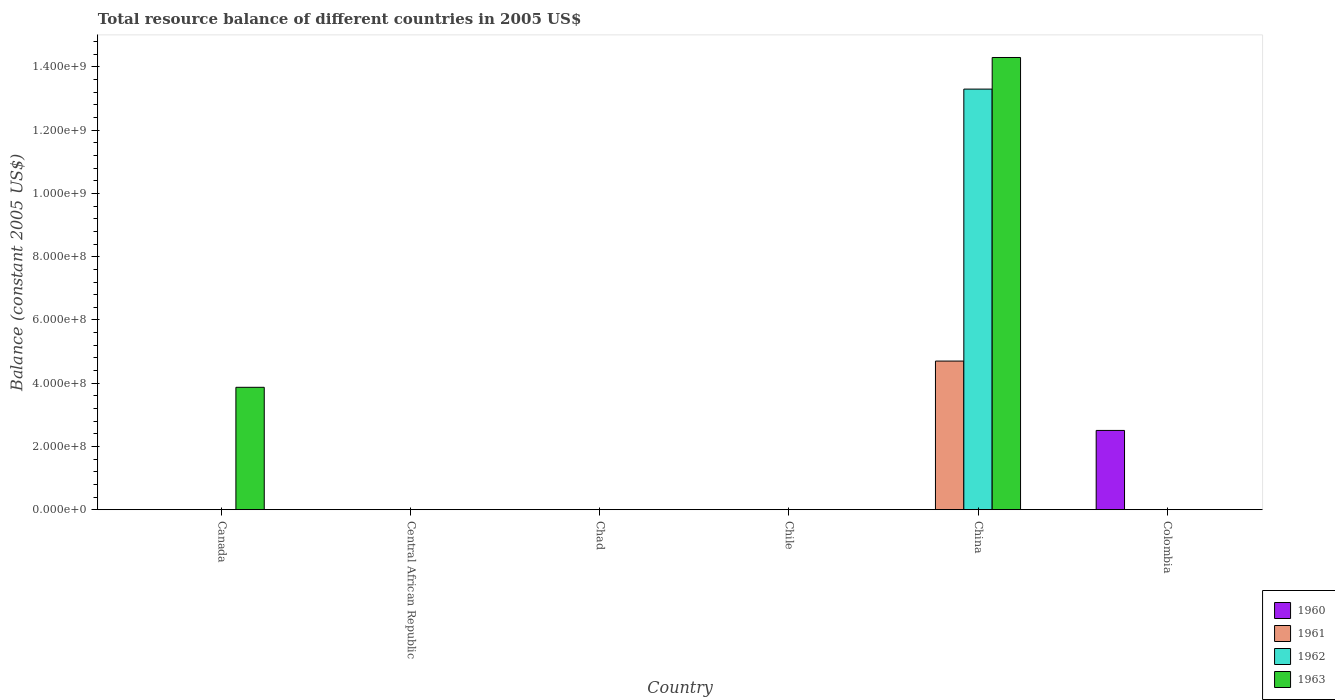How many different coloured bars are there?
Your answer should be very brief. 4. Are the number of bars per tick equal to the number of legend labels?
Provide a succinct answer. No. Are the number of bars on each tick of the X-axis equal?
Your answer should be compact. No. What is the label of the 1st group of bars from the left?
Keep it short and to the point. Canada. What is the total resource balance in 1961 in Chile?
Your answer should be very brief. 0. Across all countries, what is the maximum total resource balance in 1962?
Your response must be concise. 1.33e+09. What is the total total resource balance in 1960 in the graph?
Your answer should be compact. 2.51e+08. What is the difference between the total resource balance in 1961 in Colombia and the total resource balance in 1963 in China?
Offer a very short reply. -1.43e+09. What is the average total resource balance in 1962 per country?
Your answer should be very brief. 2.22e+08. What is the difference between the highest and the lowest total resource balance in 1962?
Provide a short and direct response. 1.33e+09. In how many countries, is the total resource balance in 1961 greater than the average total resource balance in 1961 taken over all countries?
Offer a very short reply. 1. Is it the case that in every country, the sum of the total resource balance in 1961 and total resource balance in 1960 is greater than the sum of total resource balance in 1962 and total resource balance in 1963?
Your answer should be very brief. No. Are all the bars in the graph horizontal?
Keep it short and to the point. No. Are the values on the major ticks of Y-axis written in scientific E-notation?
Your answer should be compact. Yes. Does the graph contain grids?
Keep it short and to the point. No. Where does the legend appear in the graph?
Provide a succinct answer. Bottom right. How many legend labels are there?
Make the answer very short. 4. How are the legend labels stacked?
Your answer should be very brief. Vertical. What is the title of the graph?
Keep it short and to the point. Total resource balance of different countries in 2005 US$. What is the label or title of the Y-axis?
Offer a very short reply. Balance (constant 2005 US$). What is the Balance (constant 2005 US$) in 1960 in Canada?
Ensure brevity in your answer.  0. What is the Balance (constant 2005 US$) in 1963 in Canada?
Offer a very short reply. 3.87e+08. What is the Balance (constant 2005 US$) of 1960 in Central African Republic?
Keep it short and to the point. 0. What is the Balance (constant 2005 US$) in 1961 in Central African Republic?
Provide a short and direct response. 0. What is the Balance (constant 2005 US$) in 1963 in Central African Republic?
Your response must be concise. 0. What is the Balance (constant 2005 US$) in 1960 in Chile?
Make the answer very short. 0. What is the Balance (constant 2005 US$) of 1961 in Chile?
Ensure brevity in your answer.  0. What is the Balance (constant 2005 US$) of 1961 in China?
Your response must be concise. 4.70e+08. What is the Balance (constant 2005 US$) in 1962 in China?
Your answer should be very brief. 1.33e+09. What is the Balance (constant 2005 US$) in 1963 in China?
Your answer should be very brief. 1.43e+09. What is the Balance (constant 2005 US$) in 1960 in Colombia?
Give a very brief answer. 2.51e+08. What is the Balance (constant 2005 US$) in 1962 in Colombia?
Offer a very short reply. 0. What is the Balance (constant 2005 US$) of 1963 in Colombia?
Give a very brief answer. 0. Across all countries, what is the maximum Balance (constant 2005 US$) in 1960?
Provide a succinct answer. 2.51e+08. Across all countries, what is the maximum Balance (constant 2005 US$) in 1961?
Give a very brief answer. 4.70e+08. Across all countries, what is the maximum Balance (constant 2005 US$) of 1962?
Offer a terse response. 1.33e+09. Across all countries, what is the maximum Balance (constant 2005 US$) in 1963?
Your answer should be compact. 1.43e+09. Across all countries, what is the minimum Balance (constant 2005 US$) in 1960?
Your response must be concise. 0. Across all countries, what is the minimum Balance (constant 2005 US$) in 1962?
Provide a short and direct response. 0. What is the total Balance (constant 2005 US$) of 1960 in the graph?
Make the answer very short. 2.51e+08. What is the total Balance (constant 2005 US$) of 1961 in the graph?
Keep it short and to the point. 4.70e+08. What is the total Balance (constant 2005 US$) in 1962 in the graph?
Offer a terse response. 1.33e+09. What is the total Balance (constant 2005 US$) of 1963 in the graph?
Offer a terse response. 1.82e+09. What is the difference between the Balance (constant 2005 US$) of 1963 in Canada and that in China?
Make the answer very short. -1.04e+09. What is the average Balance (constant 2005 US$) of 1960 per country?
Provide a short and direct response. 4.18e+07. What is the average Balance (constant 2005 US$) of 1961 per country?
Provide a short and direct response. 7.83e+07. What is the average Balance (constant 2005 US$) in 1962 per country?
Your answer should be very brief. 2.22e+08. What is the average Balance (constant 2005 US$) in 1963 per country?
Your answer should be very brief. 3.03e+08. What is the difference between the Balance (constant 2005 US$) in 1961 and Balance (constant 2005 US$) in 1962 in China?
Offer a very short reply. -8.60e+08. What is the difference between the Balance (constant 2005 US$) of 1961 and Balance (constant 2005 US$) of 1963 in China?
Give a very brief answer. -9.60e+08. What is the difference between the Balance (constant 2005 US$) of 1962 and Balance (constant 2005 US$) of 1963 in China?
Ensure brevity in your answer.  -1.00e+08. What is the ratio of the Balance (constant 2005 US$) of 1963 in Canada to that in China?
Your response must be concise. 0.27. What is the difference between the highest and the lowest Balance (constant 2005 US$) of 1960?
Your answer should be very brief. 2.51e+08. What is the difference between the highest and the lowest Balance (constant 2005 US$) of 1961?
Offer a very short reply. 4.70e+08. What is the difference between the highest and the lowest Balance (constant 2005 US$) of 1962?
Your response must be concise. 1.33e+09. What is the difference between the highest and the lowest Balance (constant 2005 US$) in 1963?
Provide a succinct answer. 1.43e+09. 